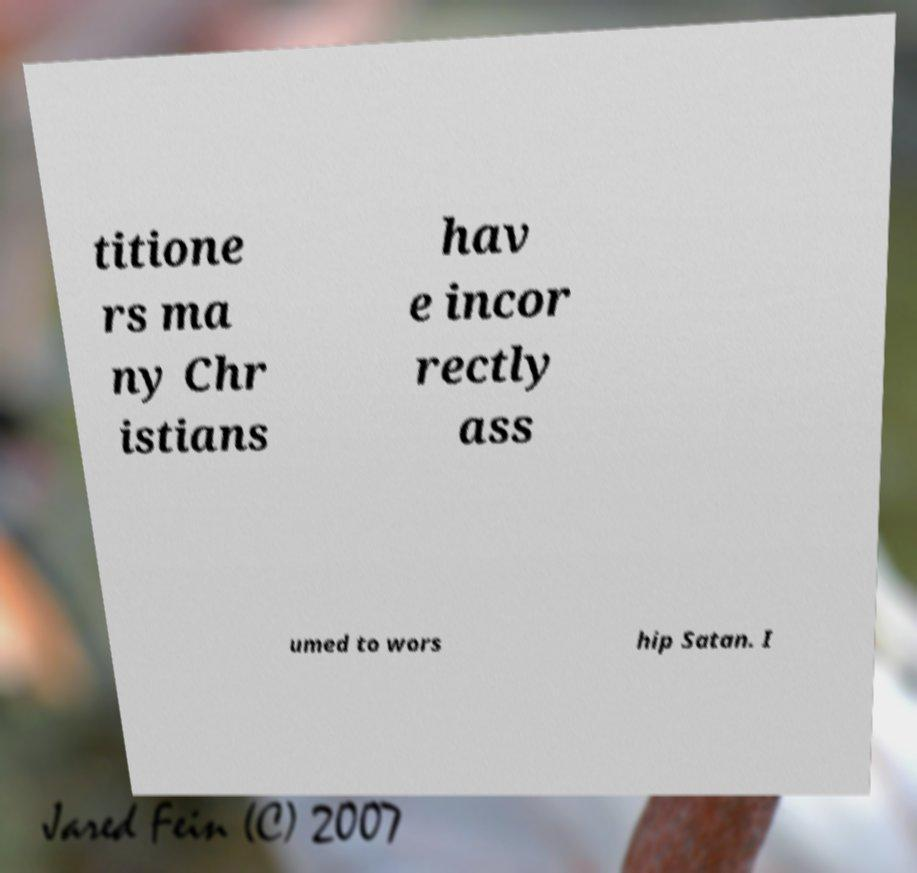Please read and relay the text visible in this image. What does it say? titione rs ma ny Chr istians hav e incor rectly ass umed to wors hip Satan. I 